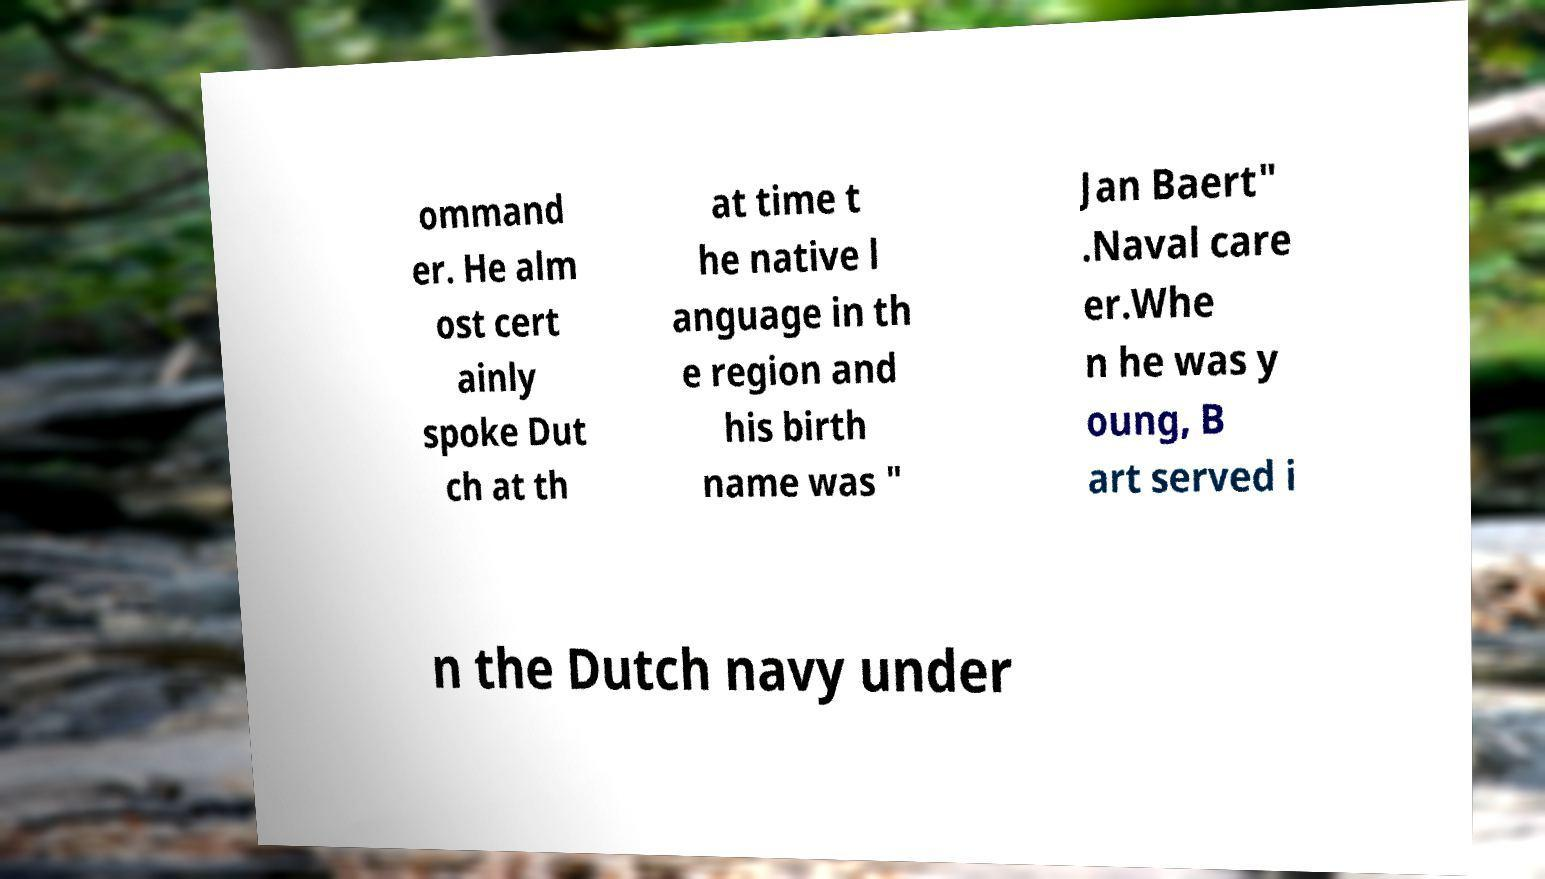For documentation purposes, I need the text within this image transcribed. Could you provide that? ommand er. He alm ost cert ainly spoke Dut ch at th at time t he native l anguage in th e region and his birth name was " Jan Baert" .Naval care er.Whe n he was y oung, B art served i n the Dutch navy under 